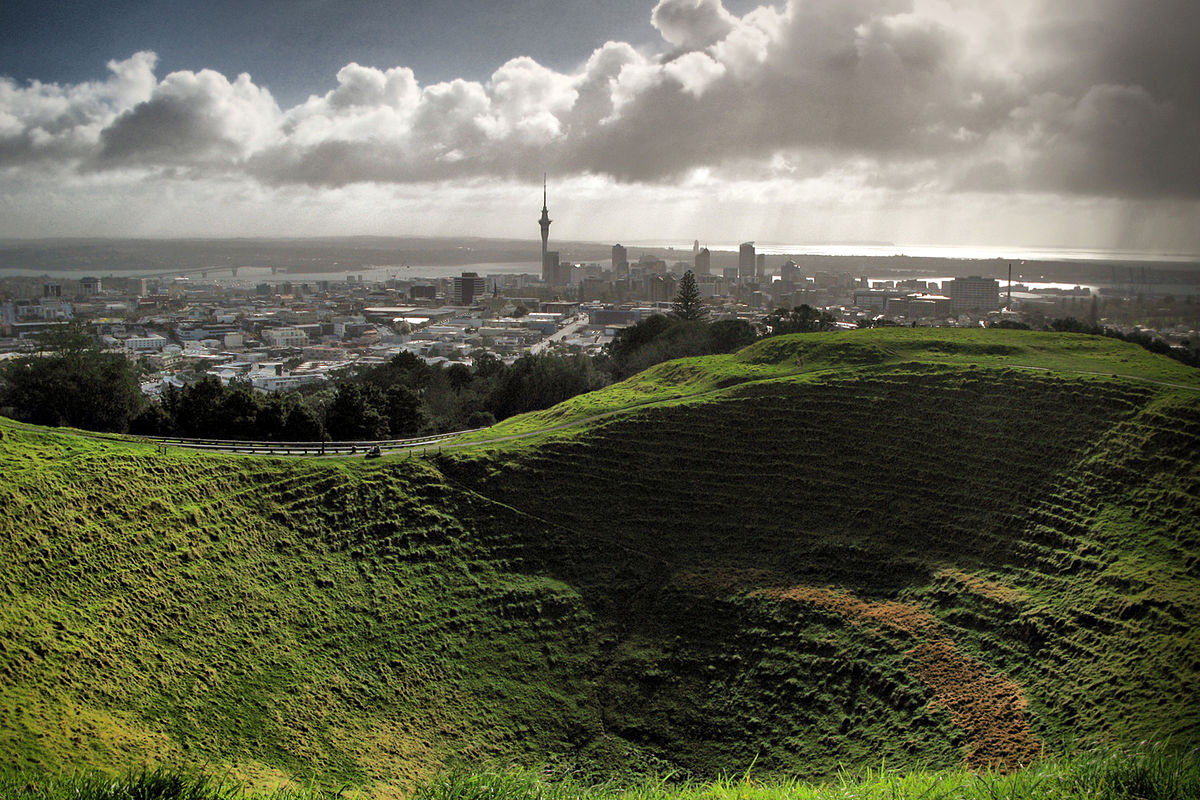Can you describe the main features of this image for me? The image features a dramatic view of the Mt Eden Crater, a significant volcanic landmark in Auckland, New Zealand. The crater's lush green bowl contrasts starkly with the sprawling urban landscape in the distance. Prominent in the urban skyline is the Auckland Sky Tower, piercing the horizon. The dynamic sky, with its play of light and shadow cast by the clouds, adds a vibrant atmosphere to the scene. This juxtaposition of natural green spaces and urban development speaks volumes about Auckland's geographic and cultural landscape. 